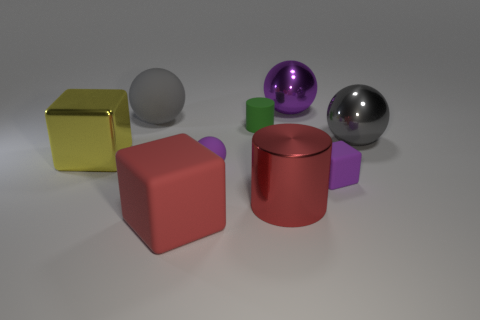Do the shiny object behind the matte cylinder and the rubber block that is right of the tiny green rubber cylinder have the same color?
Provide a short and direct response. Yes. What is the material of the small object that is the same shape as the big gray metallic thing?
Your response must be concise. Rubber. There is a large ball that is on the right side of the tiny block; is its color the same as the large matte ball?
Ensure brevity in your answer.  Yes. There is a tiny rubber object that is the same color as the small block; what shape is it?
Provide a succinct answer. Sphere. Do the large matte block and the big rubber sphere have the same color?
Provide a short and direct response. No. How many objects are purple spheres that are behind the big yellow cube or small red objects?
Offer a terse response. 1. What size is the other red cube that is the same material as the tiny cube?
Offer a terse response. Large. Is the number of gray shiny spheres in front of the red metal object greater than the number of green metallic balls?
Make the answer very short. No. There is a big red metal thing; is it the same shape as the matte object left of the big red rubber thing?
Ensure brevity in your answer.  No. What number of small objects are yellow metal objects or green spheres?
Ensure brevity in your answer.  0. 